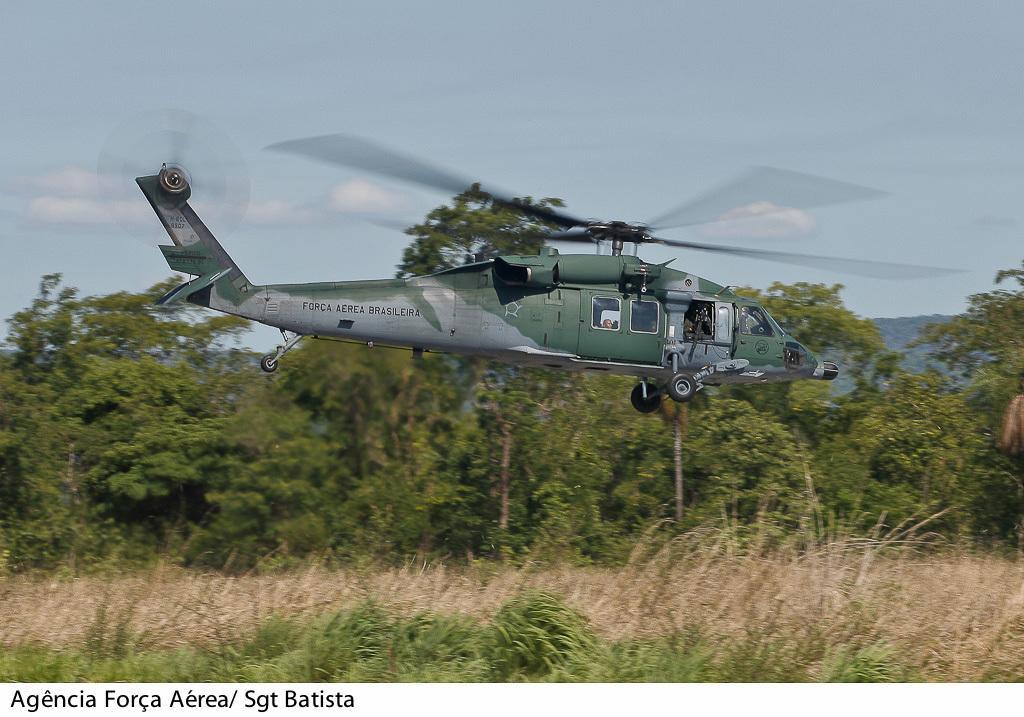Please provide a concise description of this image. In this image we can see an aircraft in the air. Behind the aircraft we can see a group of trees and plants. At the top we can see the sky. In the bottom left we can see some text. 